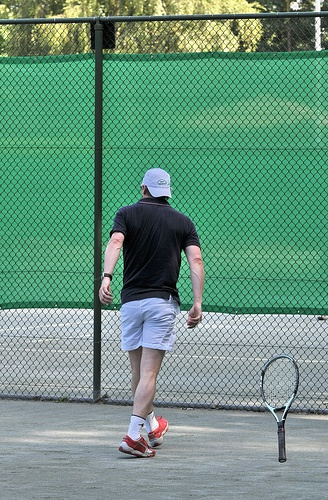Describe the objects in this image and their specific colors. I can see people in darkgreen, black, darkgray, and gray tones and tennis racket in darkgreen, darkgray, gray, black, and lightblue tones in this image. 